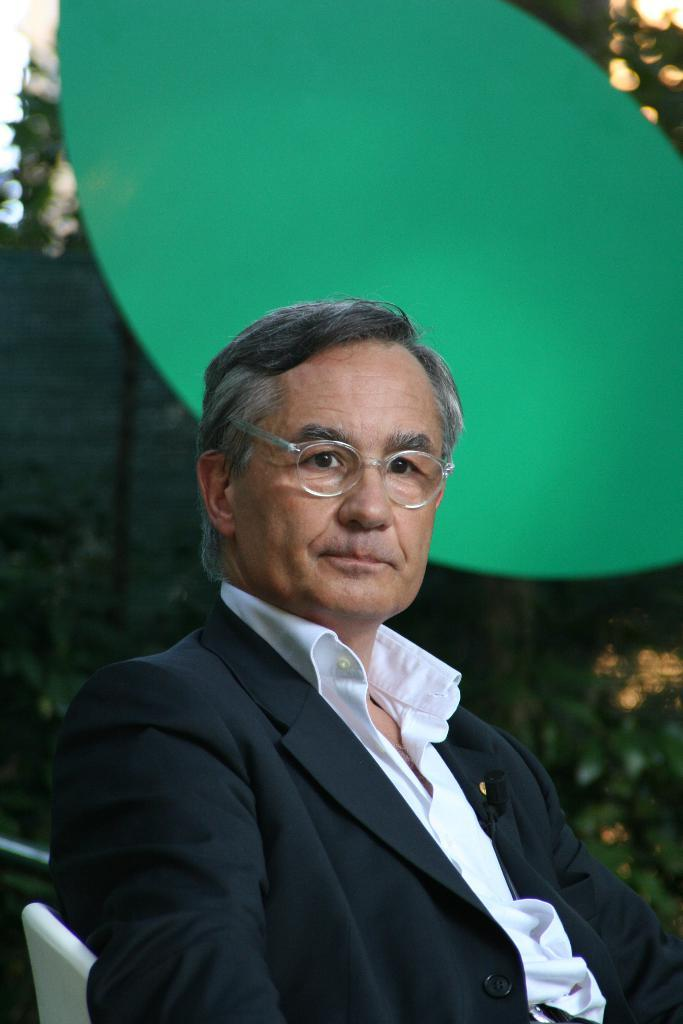What is the person in the image sitting on? The person is sitting on a white chair in the image. What type of clothing is the person wearing? The person is wearing a black blazer. What can be seen in the background of the image? There are plants in the background of the image. What type of wine is the person holding in the image? There is no wine present in the image; the person is not holding any wine. 